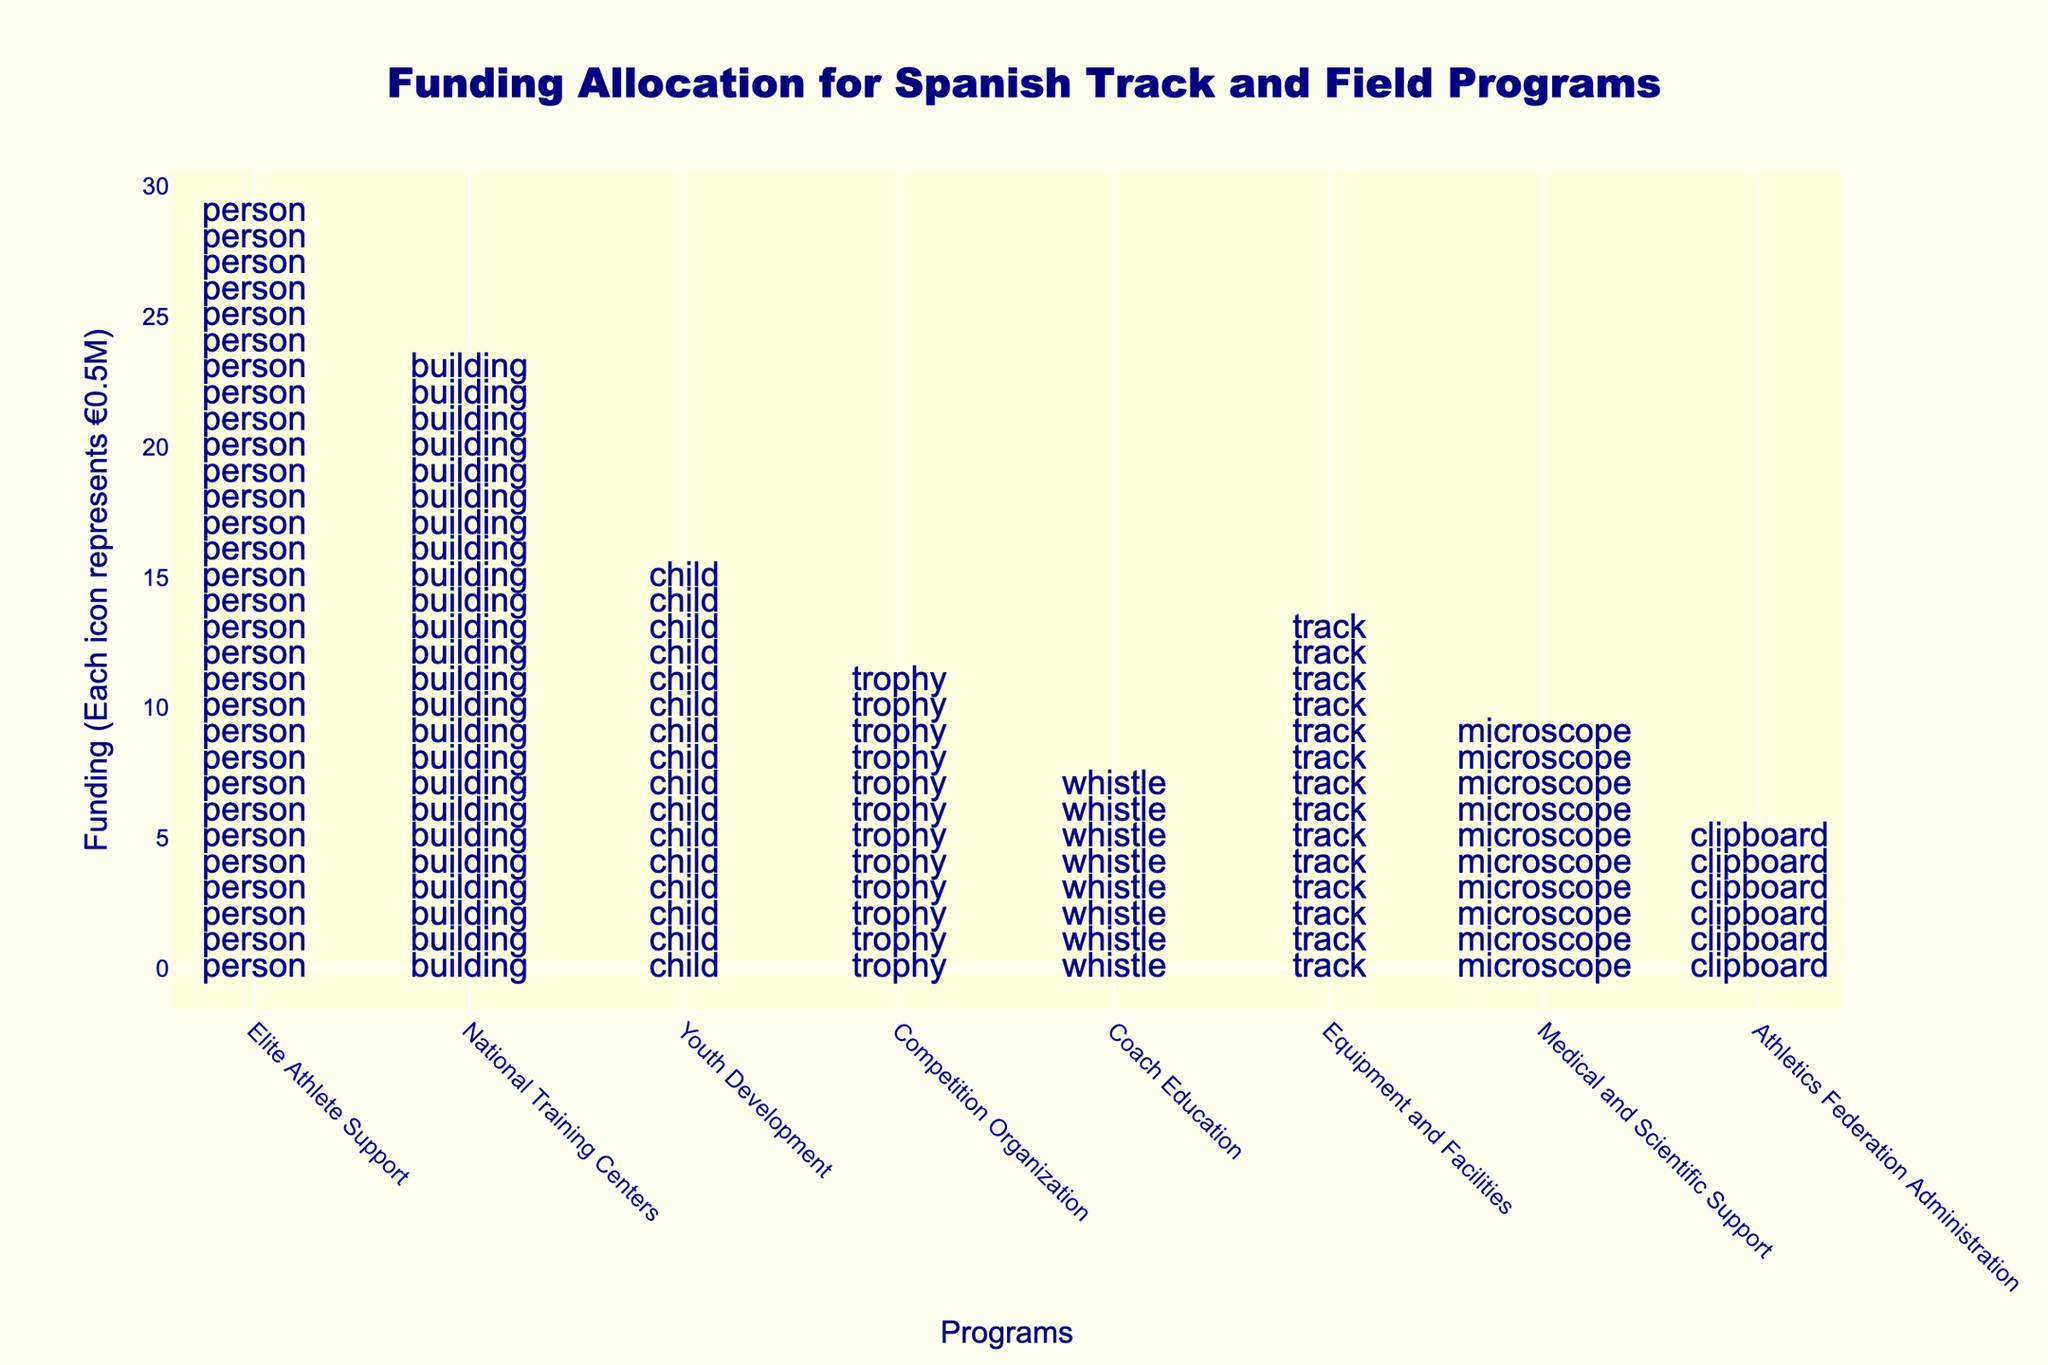What is the title of the plot? The title is displayed at the top of the plot. It reads "Funding Allocation for Spanish Track and Field Programs".
Answer: Funding Allocation for Spanish Track and Field Programs How many programs are shown in the plot? Each icon represents a different program, and there are a total of 8 different icons/programs shown on the x-axis.
Answer: 8 Which program received the highest funding? The program "Elite Athlete Support" has the most icons, indicating it received the highest funding.
Answer: Elite Athlete Support How much funding did the Youth Development program receive? Each icon represents €0.5M. Count the icons next to the "Youth Development" label to find that there are 16 icons, so 8 million euros.
Answer: 8 million euros What's the total funding for the National Training Centers and Medical and Scientific Support combined? National Training Centers have 24 icons (€12M) and Medical and Scientific Support has 10 icons (€5M). Adding them together, 12 + 5 = 17 million euros.
Answer: 17 million euros Which programs received more funding than the Competition Organization? Competition Organization has 12 icons (€6M). Programs with more icons are Elite Athlete Support (30 icons, €15M), National Training Centers (24 icons, €12M), Youth Development (16 icons, €8M), Equipment and Facilities (14 icons, €7M).
Answer: Elite Athlete Support, National Training Centers, Youth Development, Equipment and Facilities How does the funding for Coach Education compare to Athletics Federation Administration? Coach Education has 8 icons (€4M), while Athletics Federation Administration has 6 icons (€3M). Therefore, Coach Education received more funding.
Answer: Coach Education received more funding What is the total funding allocation represented in the plot? Sum all the funds: Elite Athlete Support (€15M), National Training Centers (€12M), Youth Development (€8M), Competition Organization (€6M), Coach Education (€4M), Equipment and Facilities (€7M), Medical and Scientific Support (€5M), Athletics Federation Administration (€3M). Total = 15 + 12 + 8 + 6 + 4 + 7 + 5 + 3 = 60 million euros.
Answer: 60 million euros How many more million euros does Equipment and Facilities receive compared to Coach Education? Equipment and Facilities received €7M and Coach Education received €4M. The difference in funding is 7 - 4 = 3 million euros.
Answer: 3 million euros What percentage of the total allocation does the Competition Organization receive? The total funding is €60M. The Competition Organization received €6M. The percentage is (6 / 60) * 100 = 10%.
Answer: 10% 